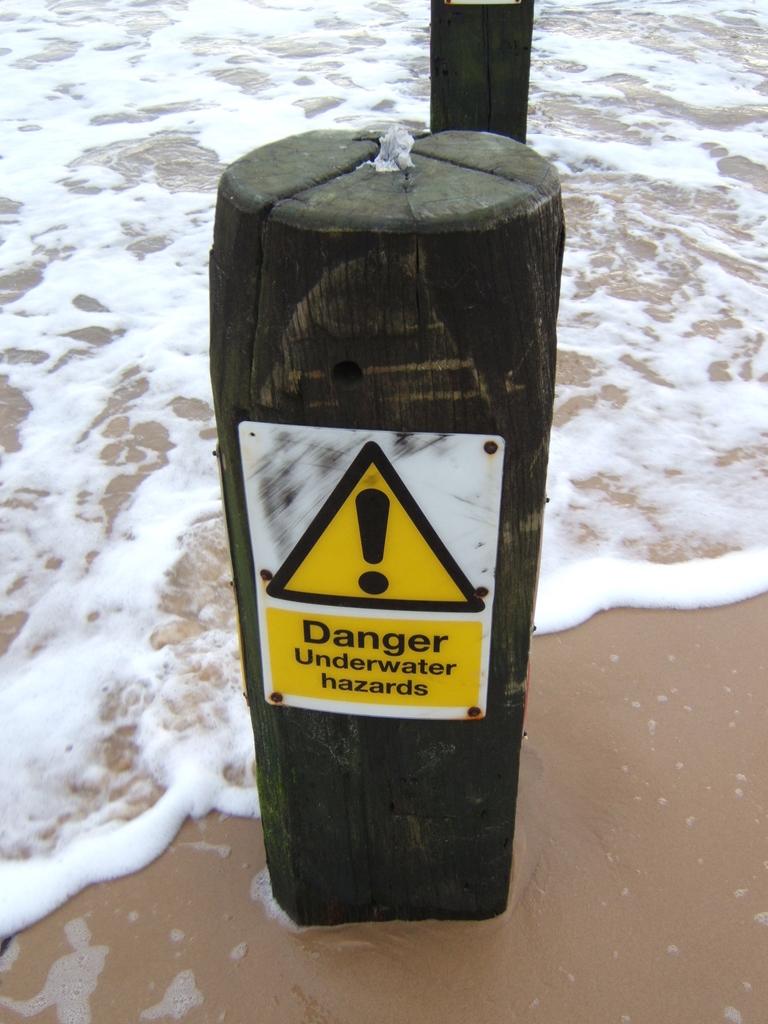Why is there danger?
Provide a succinct answer. Underwater hazards. What symbol is used to show danger in the water?
Your answer should be very brief. !. 